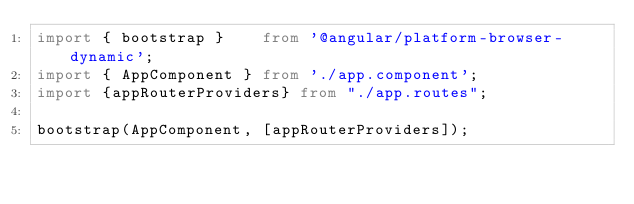<code> <loc_0><loc_0><loc_500><loc_500><_TypeScript_>import { bootstrap }    from '@angular/platform-browser-dynamic';
import { AppComponent } from './app.component';
import {appRouterProviders} from "./app.routes";

bootstrap(AppComponent, [appRouterProviders]);
</code> 